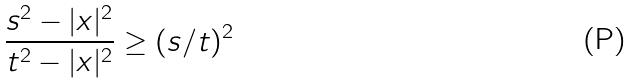Convert formula to latex. <formula><loc_0><loc_0><loc_500><loc_500>\frac { s ^ { 2 } - | x | ^ { 2 } } { t ^ { 2 } - | x | ^ { 2 } } \geq ( s / t ) ^ { 2 }</formula> 